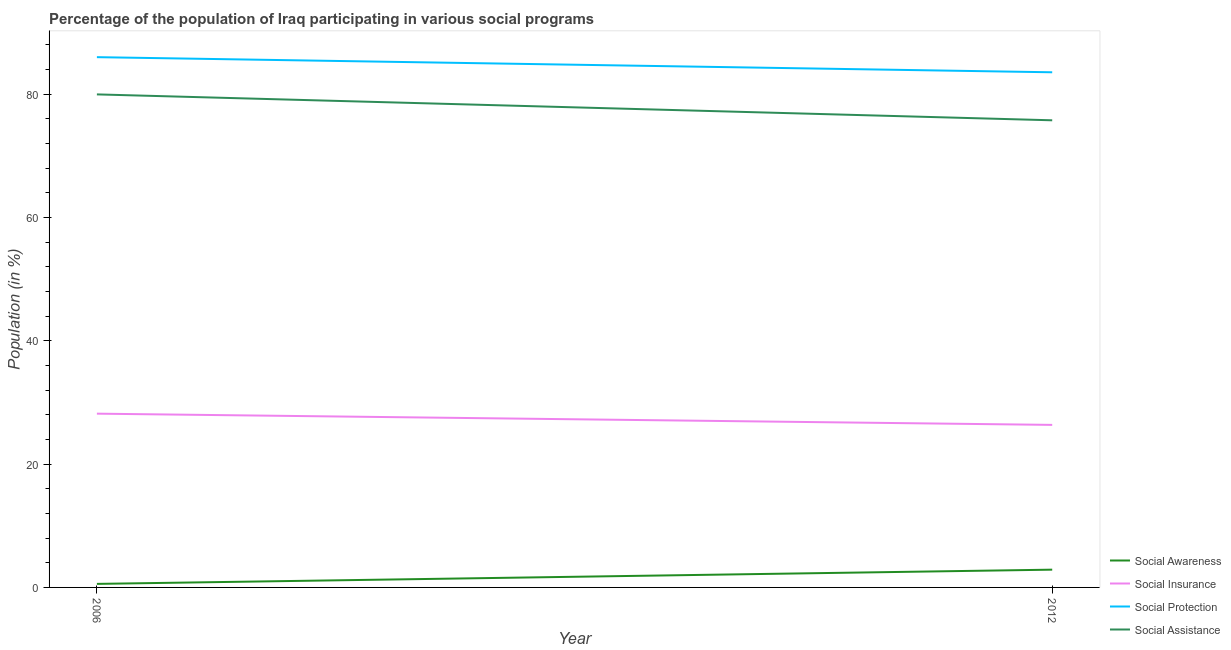How many different coloured lines are there?
Your response must be concise. 4. What is the participation of population in social assistance programs in 2006?
Ensure brevity in your answer.  79.97. Across all years, what is the maximum participation of population in social insurance programs?
Keep it short and to the point. 28.19. Across all years, what is the minimum participation of population in social protection programs?
Provide a succinct answer. 83.56. What is the total participation of population in social insurance programs in the graph?
Your answer should be very brief. 54.55. What is the difference between the participation of population in social assistance programs in 2006 and that in 2012?
Provide a short and direct response. 4.2. What is the difference between the participation of population in social insurance programs in 2012 and the participation of population in social awareness programs in 2006?
Your answer should be very brief. 25.79. What is the average participation of population in social awareness programs per year?
Give a very brief answer. 1.73. In the year 2006, what is the difference between the participation of population in social insurance programs and participation of population in social awareness programs?
Keep it short and to the point. 27.61. What is the ratio of the participation of population in social insurance programs in 2006 to that in 2012?
Offer a terse response. 1.07. Is it the case that in every year, the sum of the participation of population in social awareness programs and participation of population in social insurance programs is greater than the participation of population in social protection programs?
Your answer should be very brief. No. Does the participation of population in social protection programs monotonically increase over the years?
Keep it short and to the point. No. Is the participation of population in social insurance programs strictly less than the participation of population in social awareness programs over the years?
Your answer should be compact. No. How many years are there in the graph?
Your response must be concise. 2. Are the values on the major ticks of Y-axis written in scientific E-notation?
Offer a very short reply. No. Does the graph contain grids?
Your answer should be very brief. No. Where does the legend appear in the graph?
Offer a terse response. Bottom right. How many legend labels are there?
Offer a terse response. 4. What is the title of the graph?
Offer a very short reply. Percentage of the population of Iraq participating in various social programs . Does "Secondary" appear as one of the legend labels in the graph?
Ensure brevity in your answer.  No. What is the label or title of the Y-axis?
Make the answer very short. Population (in %). What is the Population (in %) in Social Awareness in 2006?
Your response must be concise. 0.57. What is the Population (in %) in Social Insurance in 2006?
Provide a short and direct response. 28.19. What is the Population (in %) in Social Protection in 2006?
Make the answer very short. 86.01. What is the Population (in %) in Social Assistance in 2006?
Make the answer very short. 79.97. What is the Population (in %) in Social Awareness in 2012?
Your answer should be compact. 2.88. What is the Population (in %) in Social Insurance in 2012?
Provide a short and direct response. 26.36. What is the Population (in %) of Social Protection in 2012?
Your response must be concise. 83.56. What is the Population (in %) in Social Assistance in 2012?
Your answer should be compact. 75.77. Across all years, what is the maximum Population (in %) in Social Awareness?
Make the answer very short. 2.88. Across all years, what is the maximum Population (in %) in Social Insurance?
Offer a terse response. 28.19. Across all years, what is the maximum Population (in %) of Social Protection?
Offer a very short reply. 86.01. Across all years, what is the maximum Population (in %) of Social Assistance?
Keep it short and to the point. 79.97. Across all years, what is the minimum Population (in %) in Social Awareness?
Provide a succinct answer. 0.57. Across all years, what is the minimum Population (in %) in Social Insurance?
Keep it short and to the point. 26.36. Across all years, what is the minimum Population (in %) of Social Protection?
Your answer should be very brief. 83.56. Across all years, what is the minimum Population (in %) in Social Assistance?
Provide a short and direct response. 75.77. What is the total Population (in %) of Social Awareness in the graph?
Your answer should be very brief. 3.45. What is the total Population (in %) in Social Insurance in the graph?
Provide a short and direct response. 54.55. What is the total Population (in %) in Social Protection in the graph?
Give a very brief answer. 169.57. What is the total Population (in %) of Social Assistance in the graph?
Your answer should be very brief. 155.75. What is the difference between the Population (in %) in Social Awareness in 2006 and that in 2012?
Your answer should be compact. -2.31. What is the difference between the Population (in %) in Social Insurance in 2006 and that in 2012?
Ensure brevity in your answer.  1.82. What is the difference between the Population (in %) of Social Protection in 2006 and that in 2012?
Offer a terse response. 2.45. What is the difference between the Population (in %) in Social Assistance in 2006 and that in 2012?
Provide a succinct answer. 4.2. What is the difference between the Population (in %) in Social Awareness in 2006 and the Population (in %) in Social Insurance in 2012?
Your answer should be very brief. -25.79. What is the difference between the Population (in %) in Social Awareness in 2006 and the Population (in %) in Social Protection in 2012?
Offer a very short reply. -82.99. What is the difference between the Population (in %) of Social Awareness in 2006 and the Population (in %) of Social Assistance in 2012?
Provide a succinct answer. -75.2. What is the difference between the Population (in %) in Social Insurance in 2006 and the Population (in %) in Social Protection in 2012?
Provide a short and direct response. -55.37. What is the difference between the Population (in %) in Social Insurance in 2006 and the Population (in %) in Social Assistance in 2012?
Your answer should be compact. -47.59. What is the difference between the Population (in %) of Social Protection in 2006 and the Population (in %) of Social Assistance in 2012?
Offer a terse response. 10.24. What is the average Population (in %) in Social Awareness per year?
Keep it short and to the point. 1.73. What is the average Population (in %) in Social Insurance per year?
Your response must be concise. 27.27. What is the average Population (in %) in Social Protection per year?
Provide a short and direct response. 84.79. What is the average Population (in %) in Social Assistance per year?
Keep it short and to the point. 77.87. In the year 2006, what is the difference between the Population (in %) in Social Awareness and Population (in %) in Social Insurance?
Give a very brief answer. -27.61. In the year 2006, what is the difference between the Population (in %) in Social Awareness and Population (in %) in Social Protection?
Offer a very short reply. -85.44. In the year 2006, what is the difference between the Population (in %) in Social Awareness and Population (in %) in Social Assistance?
Ensure brevity in your answer.  -79.4. In the year 2006, what is the difference between the Population (in %) of Social Insurance and Population (in %) of Social Protection?
Keep it short and to the point. -57.83. In the year 2006, what is the difference between the Population (in %) in Social Insurance and Population (in %) in Social Assistance?
Ensure brevity in your answer.  -51.79. In the year 2006, what is the difference between the Population (in %) of Social Protection and Population (in %) of Social Assistance?
Ensure brevity in your answer.  6.04. In the year 2012, what is the difference between the Population (in %) of Social Awareness and Population (in %) of Social Insurance?
Offer a terse response. -23.48. In the year 2012, what is the difference between the Population (in %) in Social Awareness and Population (in %) in Social Protection?
Your answer should be compact. -80.68. In the year 2012, what is the difference between the Population (in %) in Social Awareness and Population (in %) in Social Assistance?
Your answer should be compact. -72.89. In the year 2012, what is the difference between the Population (in %) of Social Insurance and Population (in %) of Social Protection?
Your answer should be compact. -57.2. In the year 2012, what is the difference between the Population (in %) in Social Insurance and Population (in %) in Social Assistance?
Give a very brief answer. -49.41. In the year 2012, what is the difference between the Population (in %) in Social Protection and Population (in %) in Social Assistance?
Provide a succinct answer. 7.79. What is the ratio of the Population (in %) of Social Awareness in 2006 to that in 2012?
Provide a succinct answer. 0.2. What is the ratio of the Population (in %) in Social Insurance in 2006 to that in 2012?
Your answer should be very brief. 1.07. What is the ratio of the Population (in %) of Social Protection in 2006 to that in 2012?
Your answer should be very brief. 1.03. What is the ratio of the Population (in %) of Social Assistance in 2006 to that in 2012?
Provide a short and direct response. 1.06. What is the difference between the highest and the second highest Population (in %) of Social Awareness?
Ensure brevity in your answer.  2.31. What is the difference between the highest and the second highest Population (in %) in Social Insurance?
Make the answer very short. 1.82. What is the difference between the highest and the second highest Population (in %) in Social Protection?
Your answer should be compact. 2.45. What is the difference between the highest and the second highest Population (in %) in Social Assistance?
Provide a short and direct response. 4.2. What is the difference between the highest and the lowest Population (in %) in Social Awareness?
Provide a succinct answer. 2.31. What is the difference between the highest and the lowest Population (in %) in Social Insurance?
Offer a very short reply. 1.82. What is the difference between the highest and the lowest Population (in %) of Social Protection?
Your response must be concise. 2.45. What is the difference between the highest and the lowest Population (in %) of Social Assistance?
Make the answer very short. 4.2. 